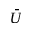<formula> <loc_0><loc_0><loc_500><loc_500>\bar { U }</formula> 